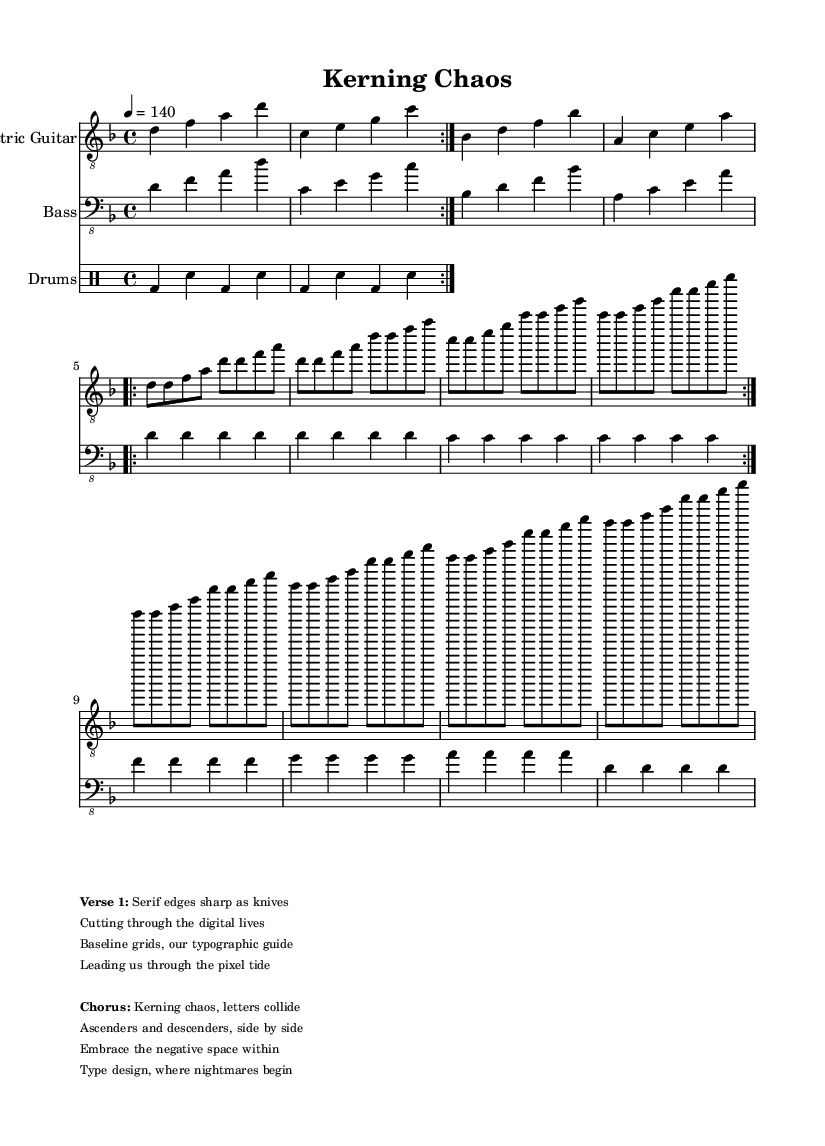What is the key signature of this music? The key signature is D minor, which indicates one flat (B flat) in the key. This can be identified at the beginning of the staff, where the flat sign is placed.
Answer: D minor What is the time signature of this music? The time signature is 4/4, which means there are four beats in each measure and a quarter note receives one beat. This is indicated at the start of the score right after the key signature.
Answer: 4/4 What is the tempo marking of this piece? The tempo marking is 4 = 140, meaning the piece should be played at a speed of 140 beats per minute, with a quarter note receiving one beat. This is found in the global section of the score.
Answer: 140 How many measures are there in the verse section? There are eight measures in the verse section, as indicated by the repeated volta structure shown in the sheet music. Each repeat of the volta indicates the same music is played again for a total of two iterations.
Answer: 8 What type of instruments are used in this score? The instruments used are Electric Guitar, Bass, and Drums, which can be seen at the start of each staff line indicating the specific instrumentation.
Answer: Electric Guitar, Bass, Drums What do the lyrics in the chorus refer to in terms of typography? The lyrics in the chorus refer to the concepts of kerning and the relationships between letters in typography, highlighting aspects like ascenders, descenders, and negative space in type design. This interpretation can be derived from the content of the lyrics provided in the markup section.
Answer: Typography concepts What does "Kerning Chaos" symbolize in the context of the song? "Kerning Chaos" symbolizes the unpredictable and complex nature of font design and letter spacing, indicating a struggle with typographical design principles. The title encapsulates the chaotic interactions of type elements in graphic design, reflecting the industrial metal genre's themes of intensity and conflict.
Answer: Unpredictable design 